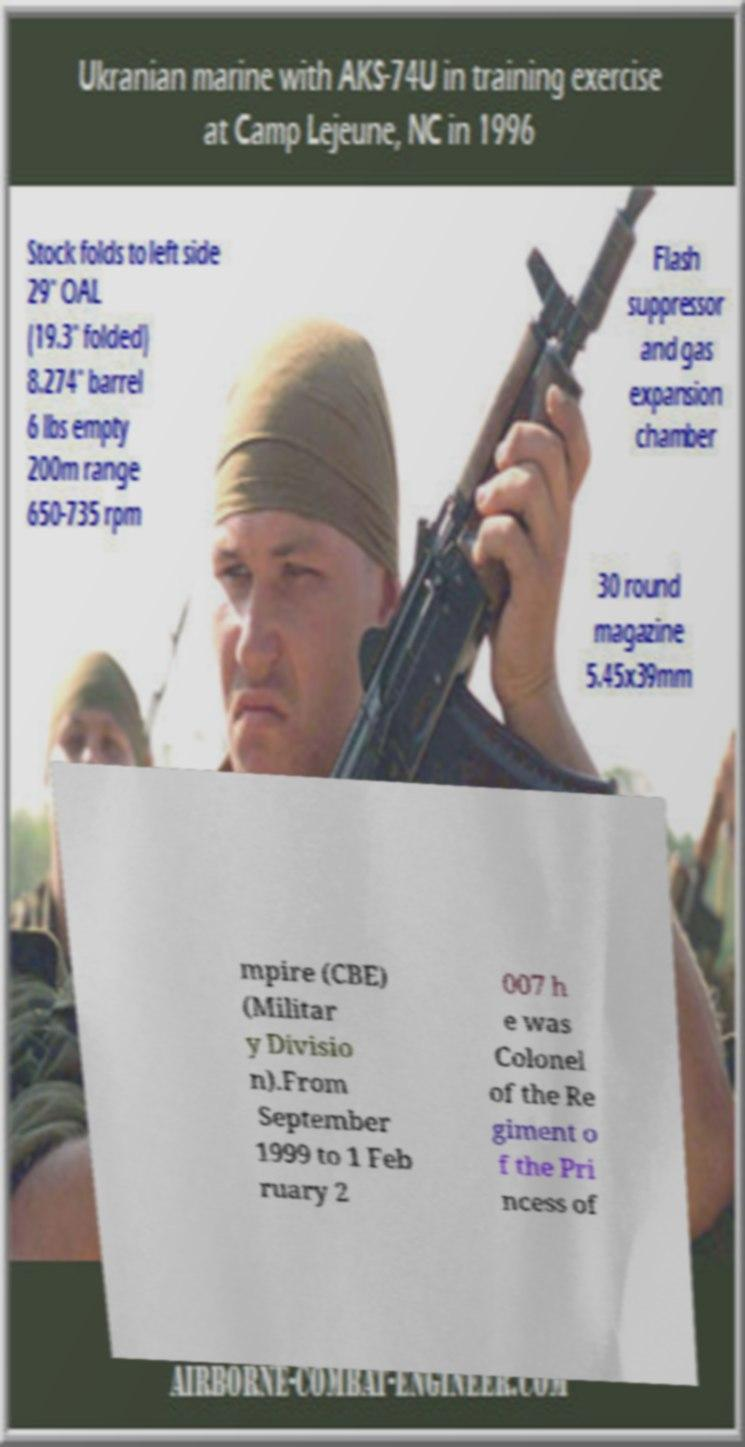What messages or text are displayed in this image? I need them in a readable, typed format. mpire (CBE) (Militar y Divisio n).From September 1999 to 1 Feb ruary 2 007 h e was Colonel of the Re giment o f the Pri ncess of 